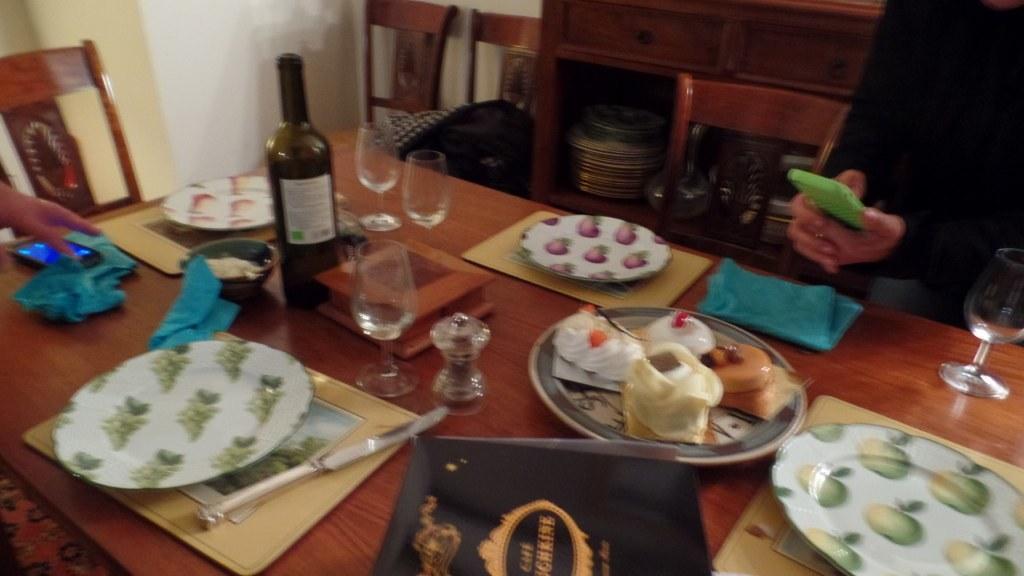In one or two sentences, can you explain what this image depicts? On the dining table we can see a wine bottle, glasses, plates on the mats, bag, cakes in a plate, napkin, mobile on a napkin, bowl, knife and a box. On the left side we can see a person's hand and on the right side a person is holding mobile in the hands. In the background there are chairs, wall and plates on the rack of a cupboard table. 